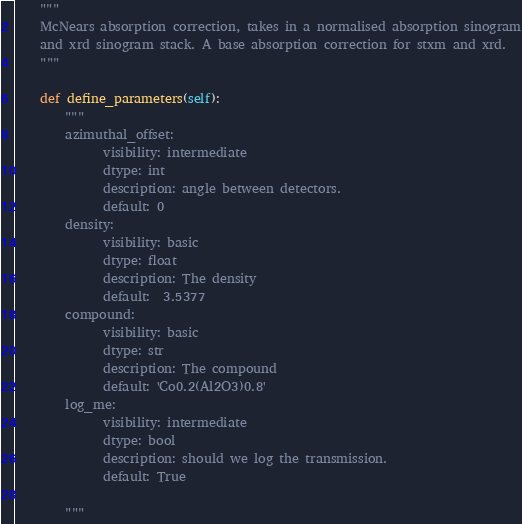Convert code to text. <code><loc_0><loc_0><loc_500><loc_500><_Python_>    """
    McNears absorption correction, takes in a normalised absorption sinogram
    and xrd sinogram stack. A base absorption correction for stxm and xrd.
    """

    def define_parameters(self):
        """
        azimuthal_offset:
              visibility: intermediate
              dtype: int
              description: angle between detectors.
              default: 0
        density:
              visibility: basic
              dtype: float
              description: The density
              default:  3.5377
        compound:
              visibility: basic
              dtype: str
              description: The compound
              default: 'Co0.2(Al2O3)0.8'
        log_me:
              visibility: intermediate
              dtype: bool
              description: should we log the transmission.
              default: True

        """</code> 